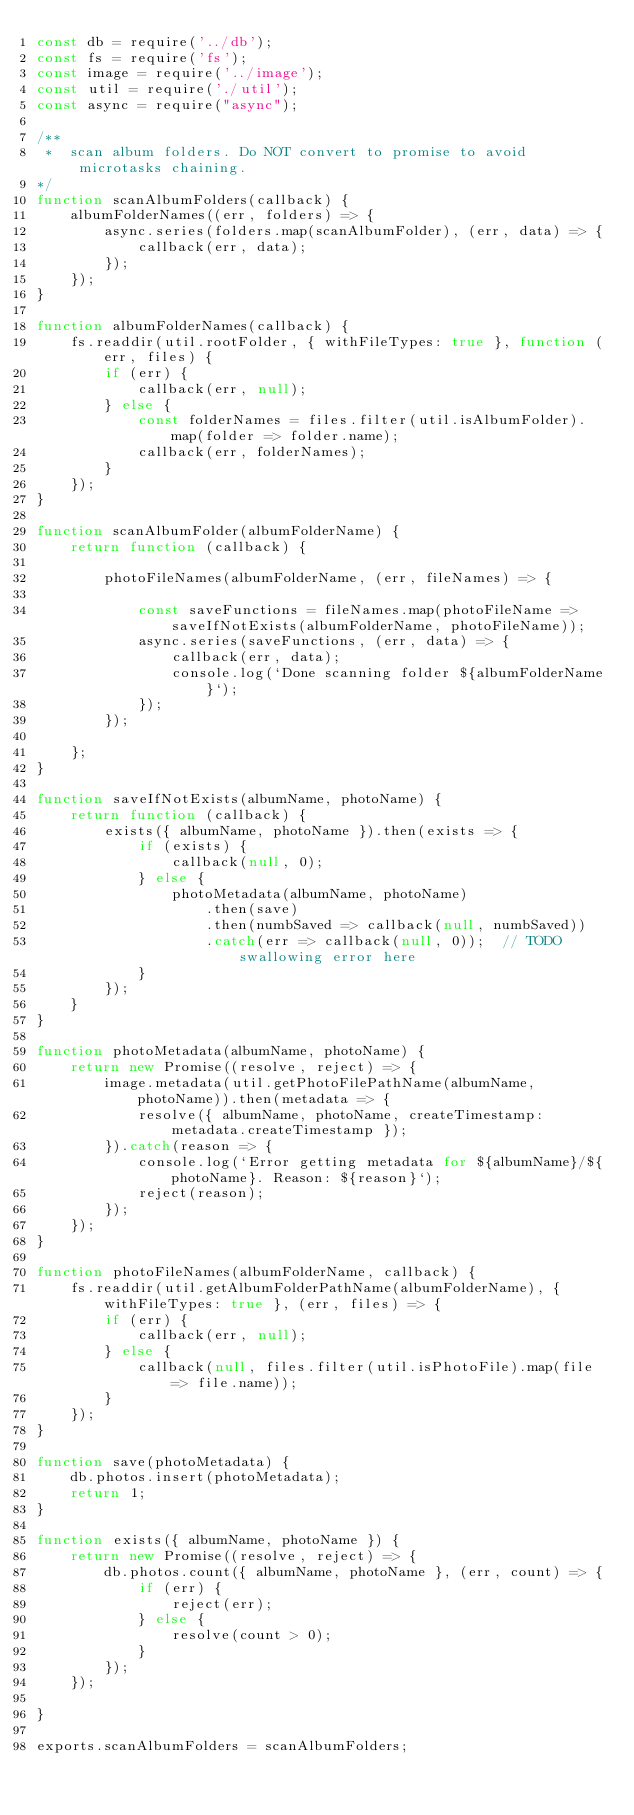<code> <loc_0><loc_0><loc_500><loc_500><_JavaScript_>const db = require('../db');
const fs = require('fs');
const image = require('../image');
const util = require('./util');
const async = require("async");

/**
 *  scan album folders. Do NOT convert to promise to avoid microtasks chaining.
*/
function scanAlbumFolders(callback) {
    albumFolderNames((err, folders) => {
        async.series(folders.map(scanAlbumFolder), (err, data) => {
            callback(err, data);
        });
    });
}

function albumFolderNames(callback) {
    fs.readdir(util.rootFolder, { withFileTypes: true }, function (err, files) {
        if (err) {
            callback(err, null);
        } else {
            const folderNames = files.filter(util.isAlbumFolder).map(folder => folder.name);
            callback(err, folderNames);
        }
    });
}

function scanAlbumFolder(albumFolderName) {
    return function (callback) {

        photoFileNames(albumFolderName, (err, fileNames) => {

            const saveFunctions = fileNames.map(photoFileName => saveIfNotExists(albumFolderName, photoFileName));
            async.series(saveFunctions, (err, data) => {
                callback(err, data);
                console.log(`Done scanning folder ${albumFolderName}`);
            });
        });

    };
}

function saveIfNotExists(albumName, photoName) {
    return function (callback) {
        exists({ albumName, photoName }).then(exists => {
            if (exists) {
                callback(null, 0);
            } else {
                photoMetadata(albumName, photoName)
                    .then(save)
                    .then(numbSaved => callback(null, numbSaved))
                    .catch(err => callback(null, 0));  // TODO swallowing error here
            }
        });
    }
}

function photoMetadata(albumName, photoName) {
    return new Promise((resolve, reject) => {
        image.metadata(util.getPhotoFilePathName(albumName, photoName)).then(metadata => {
            resolve({ albumName, photoName, createTimestamp: metadata.createTimestamp });
        }).catch(reason => {
            console.log(`Error getting metadata for ${albumName}/${photoName}. Reason: ${reason}`);
            reject(reason);
        });
    });
}

function photoFileNames(albumFolderName, callback) {
    fs.readdir(util.getAlbumFolderPathName(albumFolderName), { withFileTypes: true }, (err, files) => {
        if (err) {
            callback(err, null);
        } else {
            callback(null, files.filter(util.isPhotoFile).map(file => file.name));
        }
    });
}

function save(photoMetadata) {
    db.photos.insert(photoMetadata);
    return 1;
}

function exists({ albumName, photoName }) {
    return new Promise((resolve, reject) => {
        db.photos.count({ albumName, photoName }, (err, count) => {
            if (err) {
                reject(err);
            } else {
                resolve(count > 0);
            }
        });
    });

}

exports.scanAlbumFolders = scanAlbumFolders;
</code> 